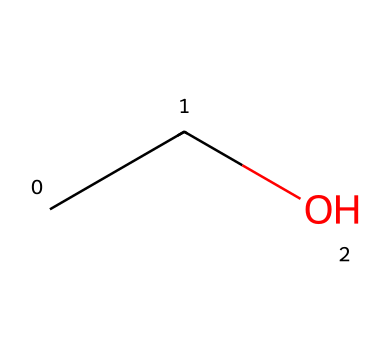What is the name of this chemical? The SMILES representation "CCO" corresponds to ethanol, which is a common alcohol. The first part "CC" indicates two carbon atoms bonded together, and "O" signifies the presence of a hydroxyl group.
Answer: ethanol How many carbon atoms are in this structure? The SMILES code "CCO" reveals there are two "C" letters, indicating two carbon atoms present in the structure.
Answer: 2 What is the main functional group in this compound? The "O" in the SMILES representation "CCO" denotes the hydroxyl group, which characterizes the functional group of alcohols, specifically making this compound an alcohol.
Answer: hydroxyl What is the total number of hydrogen atoms in this compound? Each carbon atom (2 total) typically bonds with three hydrogen atoms, but with one hydroxyl group present, the hydrogen count adjusts. The formula CH3CH2OH leads to a total of 6 hydrogen atoms, accounting for all standard bonding rules.
Answer: 6 Is this compound soluble in water? Ethanol is known for its ability to mix well in water due to the hydrophilic nature of its hydroxyl group. The presence of this functional group allows ethanol to engage in hydrogen bonding with water molecules.
Answer: yes 